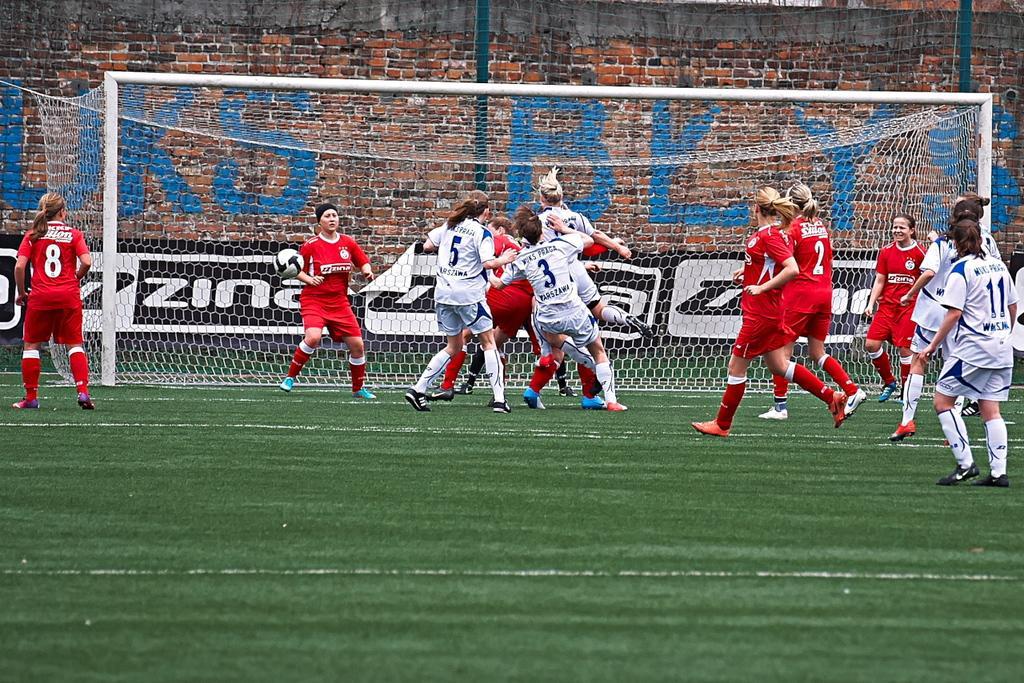Could you give a brief overview of what you see in this image? In this picture I can see the grass in front, on which there are number of women who are wearing jerseys, which are of white and red in color. In the middle of this image I can see a goal post. In the background I can see the wall, on which there is something written. 